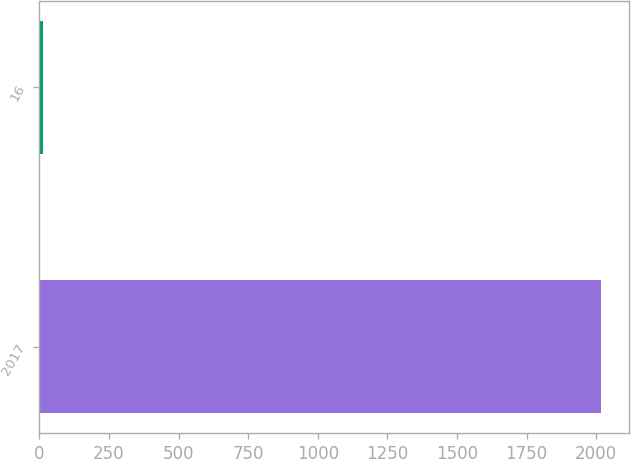<chart> <loc_0><loc_0><loc_500><loc_500><bar_chart><fcel>2017<fcel>16<nl><fcel>2018<fcel>14<nl></chart> 